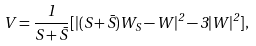Convert formula to latex. <formula><loc_0><loc_0><loc_500><loc_500>V = \frac { 1 } { S + \bar { S } } [ | ( S + \bar { S } ) W _ { S } - W | ^ { 2 } - 3 | W | ^ { 2 } ] ,</formula> 